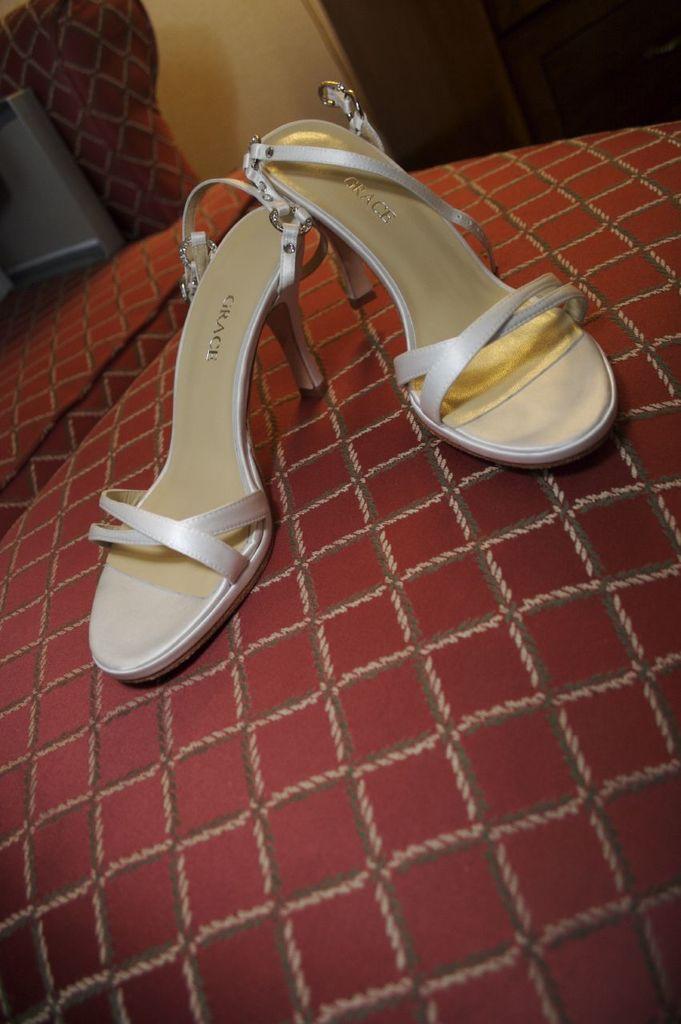In one or two sentences, can you explain what this image depicts? We can see footwear on the red surface and we can see chair and wall. 